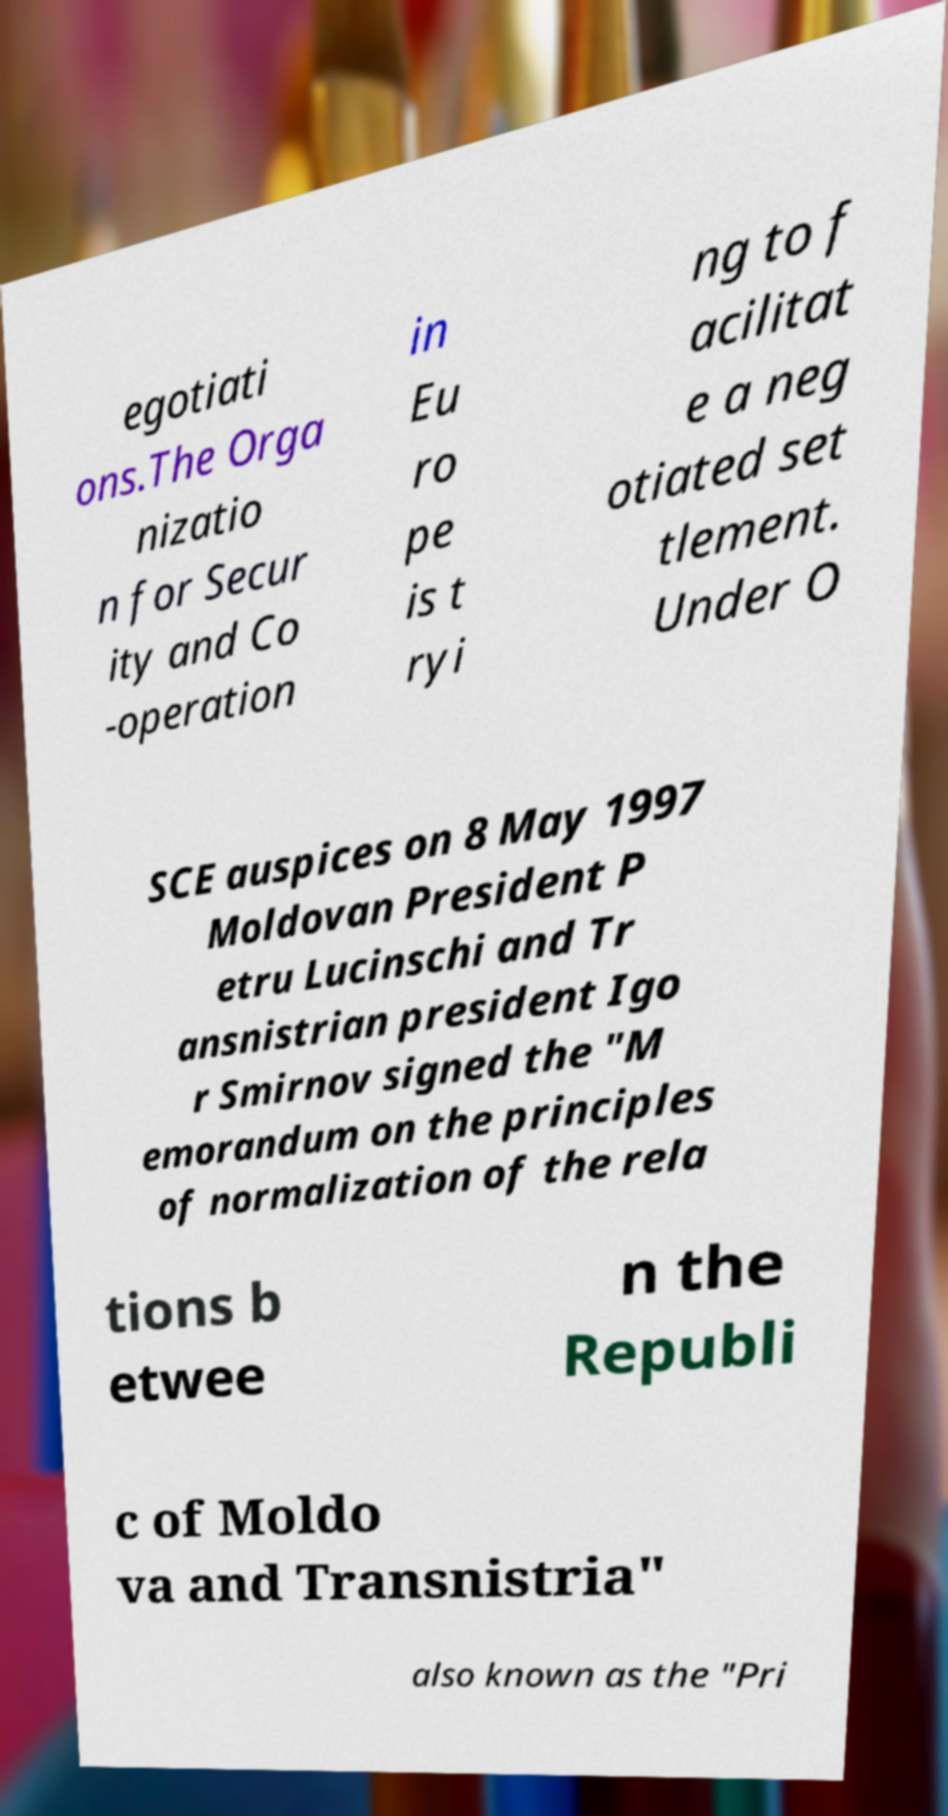Please read and relay the text visible in this image. What does it say? egotiati ons.The Orga nizatio n for Secur ity and Co -operation in Eu ro pe is t ryi ng to f acilitat e a neg otiated set tlement. Under O SCE auspices on 8 May 1997 Moldovan President P etru Lucinschi and Tr ansnistrian president Igo r Smirnov signed the "M emorandum on the principles of normalization of the rela tions b etwee n the Republi c of Moldo va and Transnistria" also known as the "Pri 